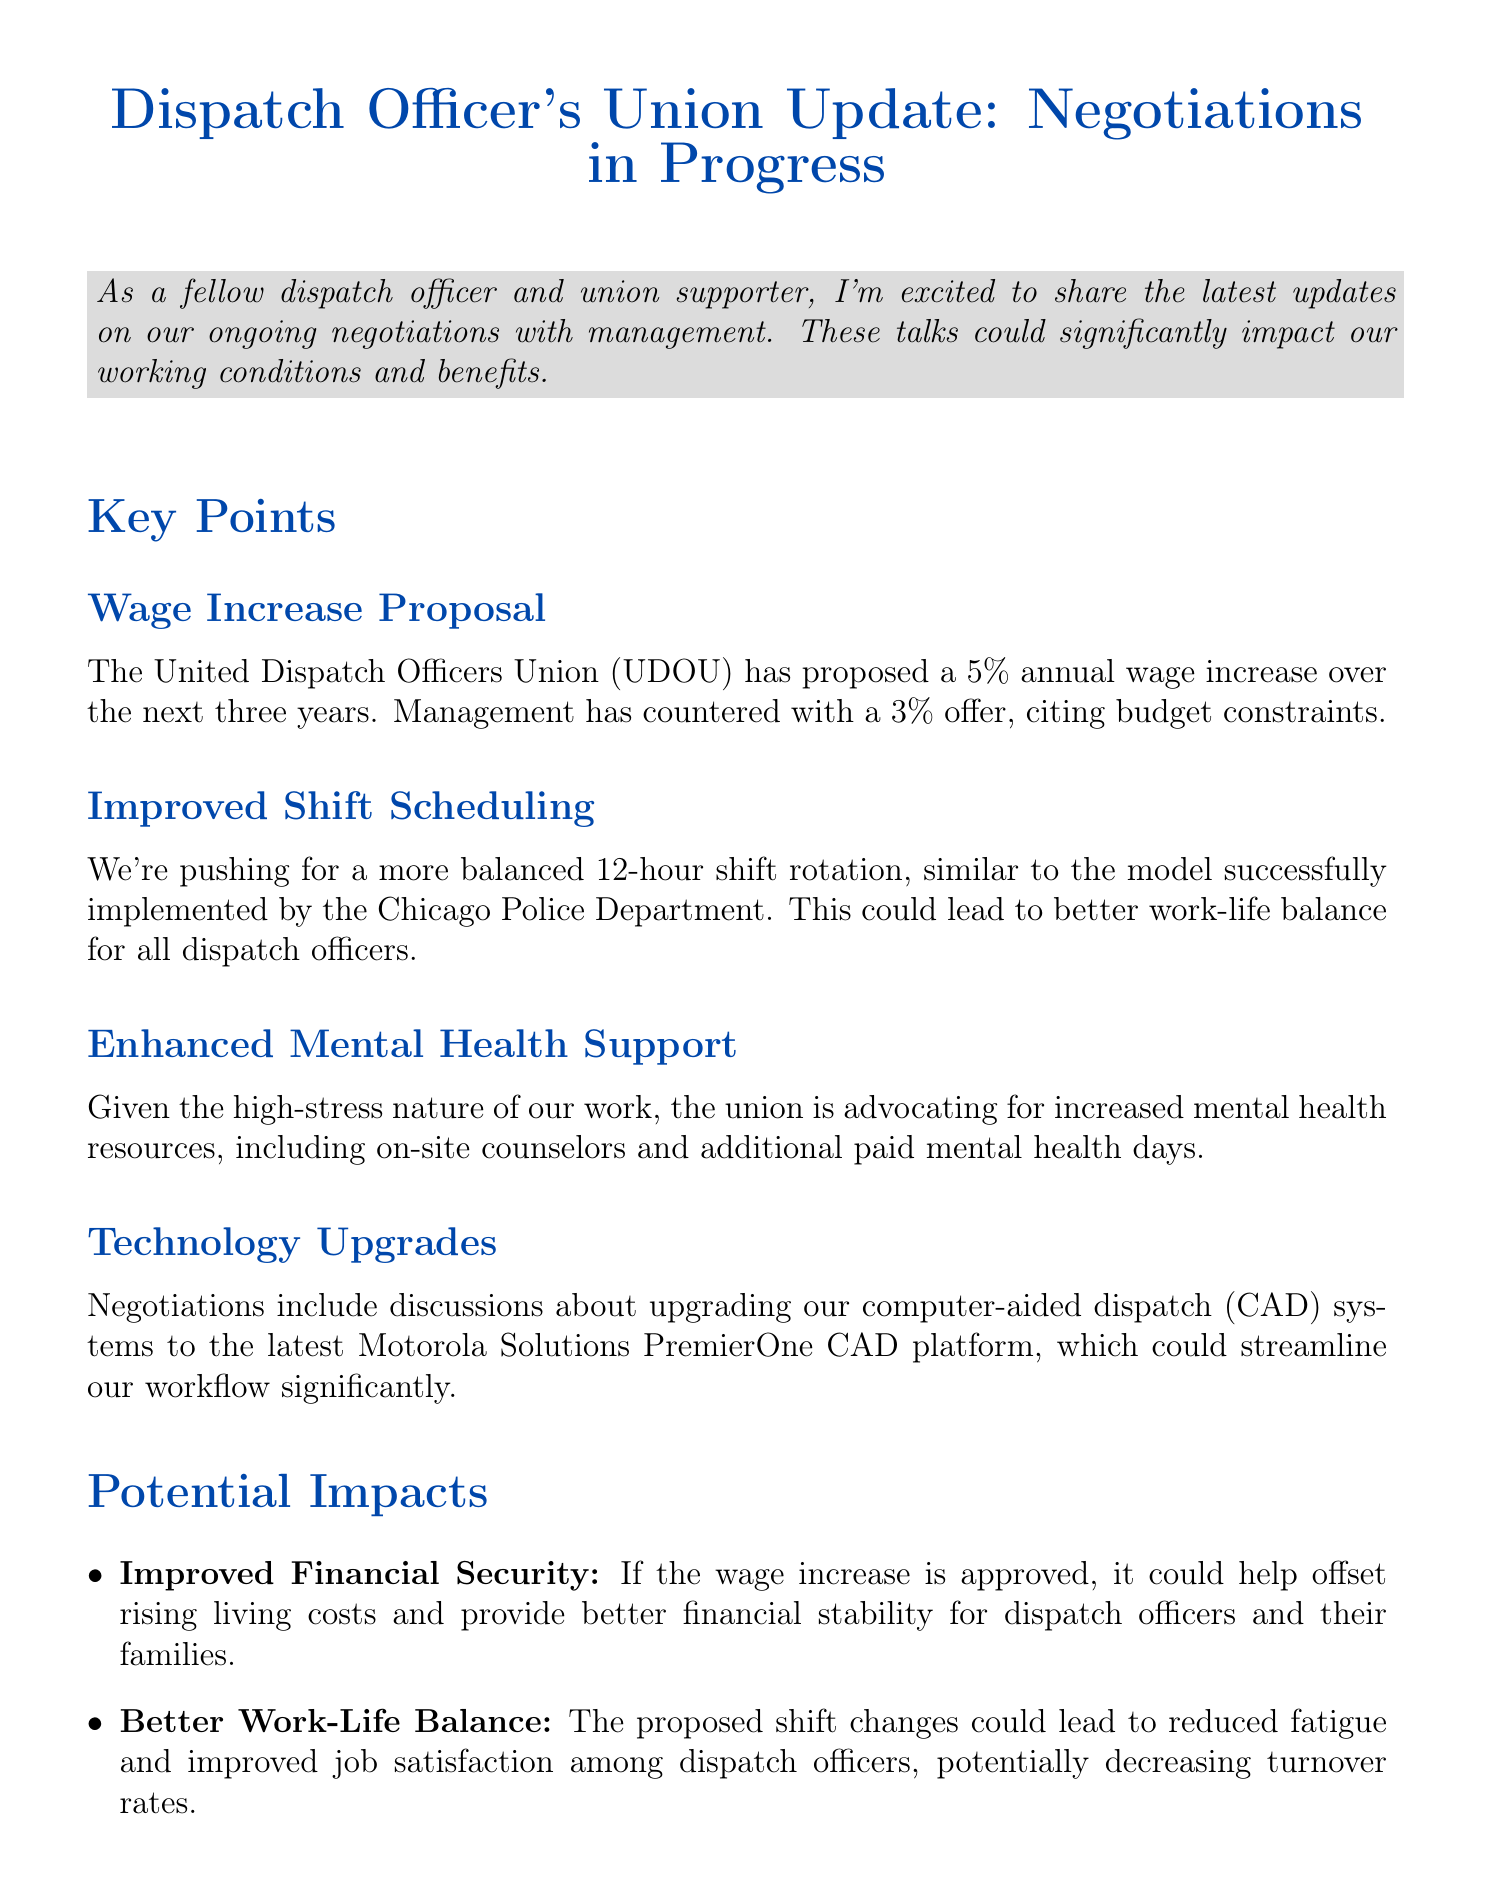What is the proposed wage increase percentage? The proposed wage increase is 5% annually over the next three years.
Answer: 5% Who is the UDOU President? The document states that UDOU President Sarah Johnson will provide updates at the Town Hall Meeting.
Answer: Sarah Johnson What is the date of the Town Hall Meeting? The date of the Town Hall Meeting is mentioned in the document.
Answer: June 15, 2023 What is one of the key points regarding shift scheduling? The union is pushing for a more balanced 12-hour shift rotation.
Answer: 12-hour shift rotation What potential impact could arise from better mental health support? Enhanced job performance could result from improved mental health support.
Answer: Enhanced job performance Where will the Solidarity Picnic take place? The location for the Solidarity Picnic is specified in the document.
Answer: Riverside Park What technology is being discussed for upgrades? The upgrades include discussions about the Motorola Solutions PremierOne CAD platform.
Answer: Motorola Solutions PremierOne CAD What is a key goal of the union negotiations? A key goal is to improve working conditions for dispatch officers.
Answer: Improve working conditions 